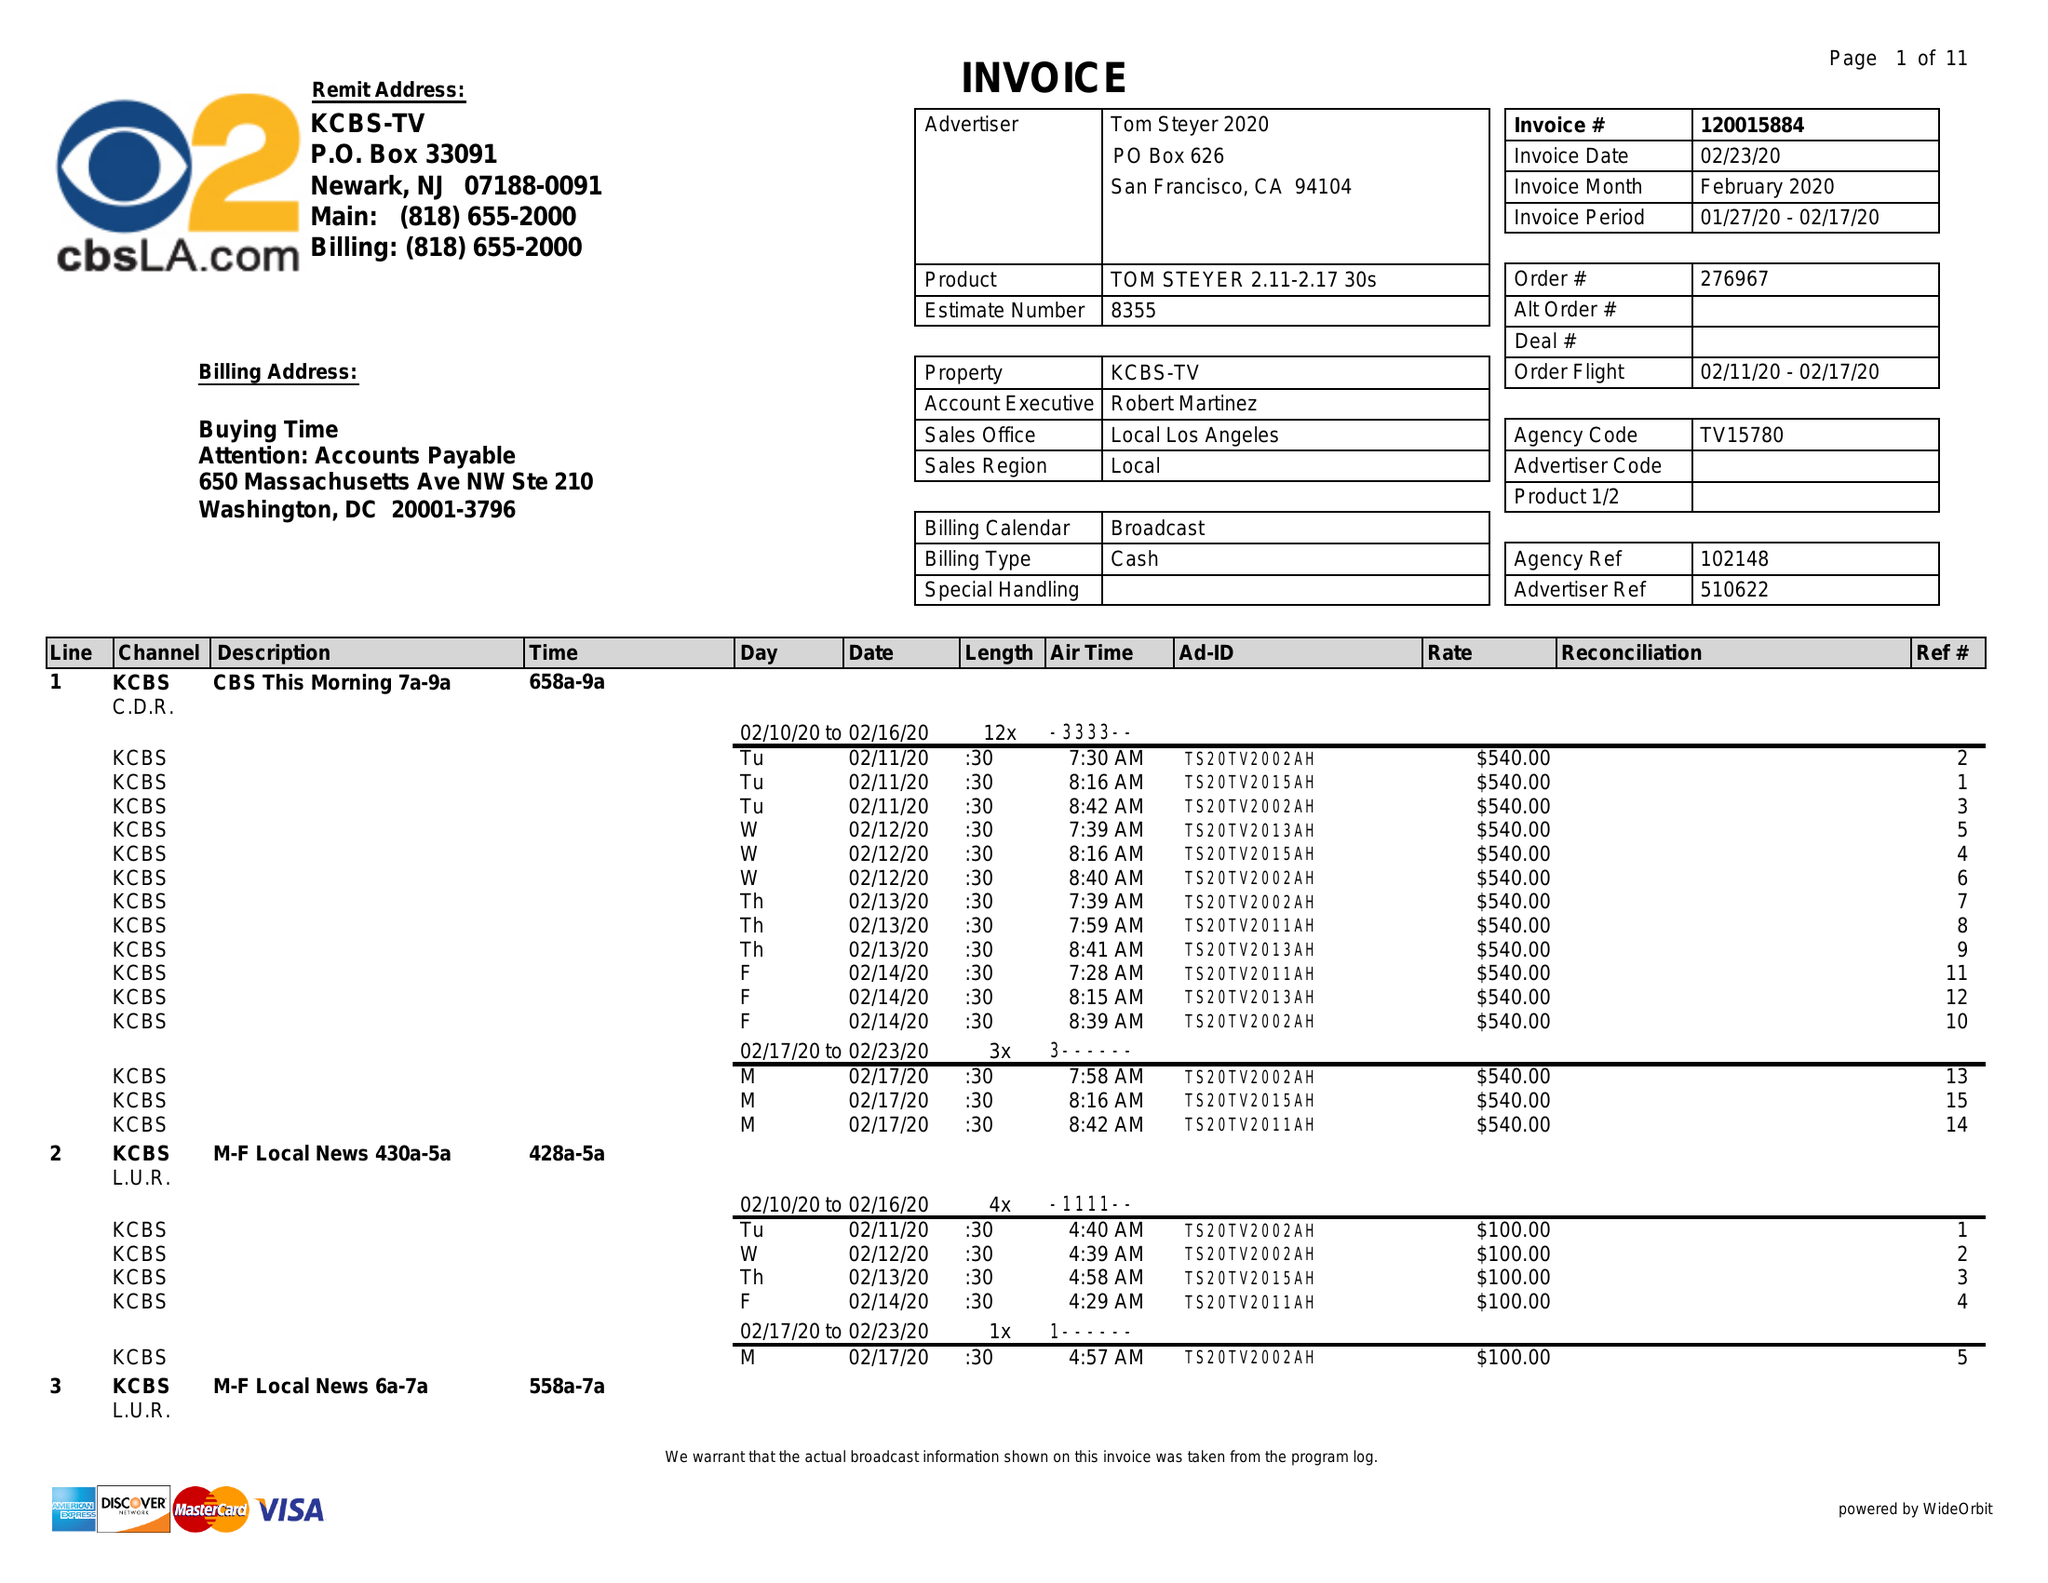What is the value for the gross_amount?
Answer the question using a single word or phrase. 186240.00 